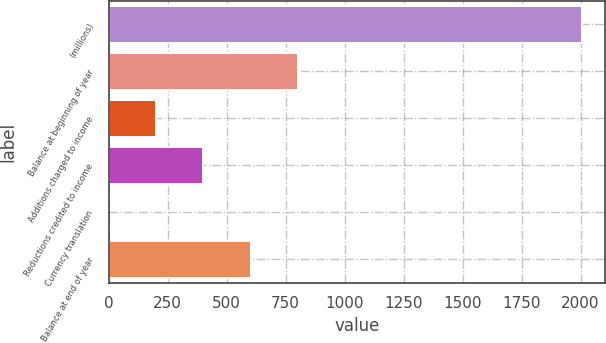Convert chart. <chart><loc_0><loc_0><loc_500><loc_500><bar_chart><fcel>(millions)<fcel>Balance at beginning of year<fcel>Additions charged to income<fcel>Reductions credited to income<fcel>Currency translation<fcel>Balance at end of year<nl><fcel>2005<fcel>802.06<fcel>200.59<fcel>401.08<fcel>0.1<fcel>601.57<nl></chart> 